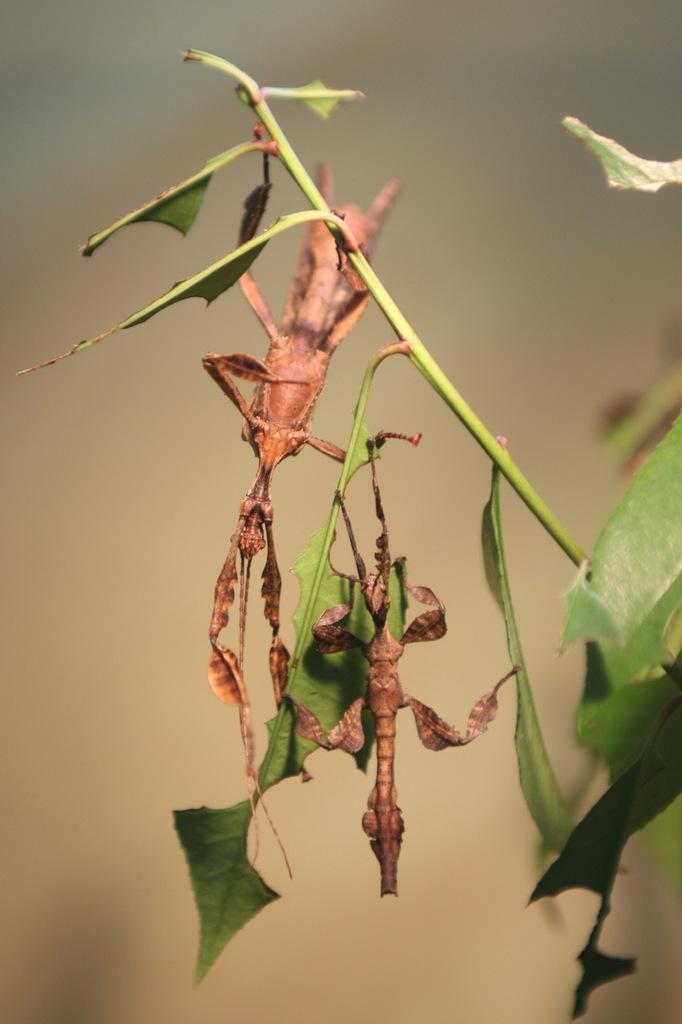Describe this image in one or two sentences. In this picture we can see there are insects to the steam and behind the insects there is blurred background. 